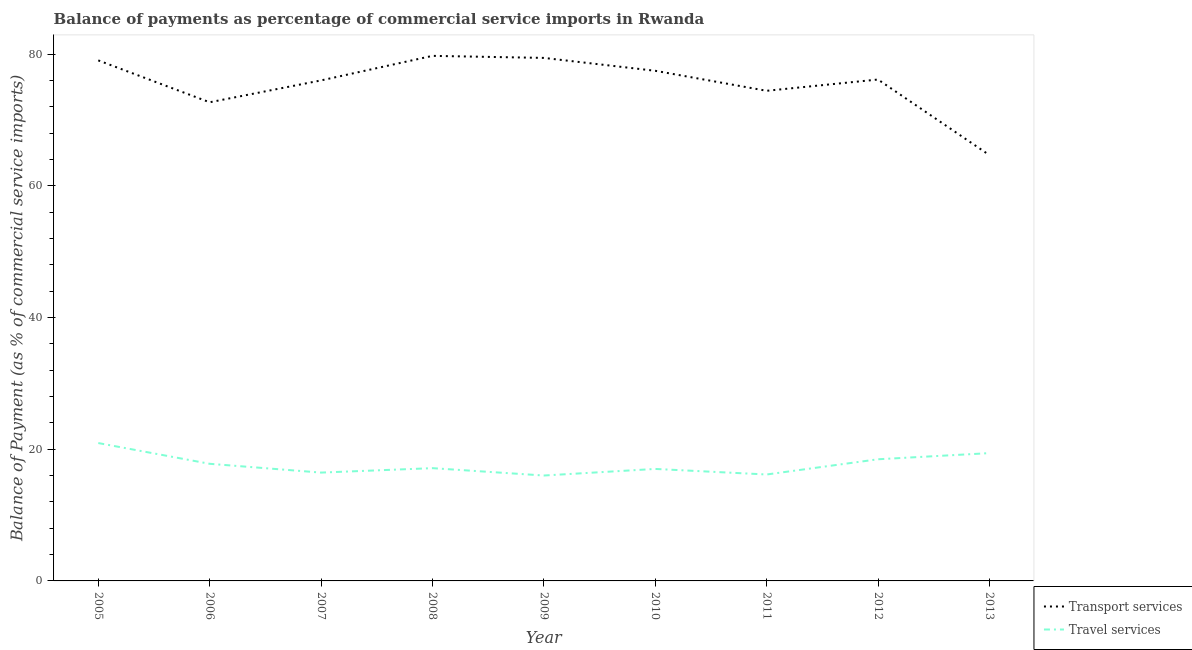How many different coloured lines are there?
Your answer should be compact. 2. What is the balance of payments of transport services in 2010?
Keep it short and to the point. 77.48. Across all years, what is the maximum balance of payments of travel services?
Provide a short and direct response. 20.94. Across all years, what is the minimum balance of payments of transport services?
Your answer should be very brief. 64.68. In which year was the balance of payments of travel services maximum?
Offer a very short reply. 2005. What is the total balance of payments of travel services in the graph?
Ensure brevity in your answer.  159.38. What is the difference between the balance of payments of transport services in 2007 and that in 2011?
Offer a very short reply. 1.58. What is the difference between the balance of payments of transport services in 2012 and the balance of payments of travel services in 2013?
Provide a short and direct response. 56.74. What is the average balance of payments of travel services per year?
Offer a very short reply. 17.71. In the year 2013, what is the difference between the balance of payments of transport services and balance of payments of travel services?
Keep it short and to the point. 45.26. What is the ratio of the balance of payments of travel services in 2009 to that in 2011?
Provide a short and direct response. 0.99. What is the difference between the highest and the second highest balance of payments of transport services?
Offer a very short reply. 0.31. What is the difference between the highest and the lowest balance of payments of travel services?
Offer a very short reply. 4.93. In how many years, is the balance of payments of transport services greater than the average balance of payments of transport services taken over all years?
Offer a very short reply. 6. Is the sum of the balance of payments of transport services in 2005 and 2012 greater than the maximum balance of payments of travel services across all years?
Offer a very short reply. Yes. Does the balance of payments of travel services monotonically increase over the years?
Ensure brevity in your answer.  No. Is the balance of payments of travel services strictly greater than the balance of payments of transport services over the years?
Provide a succinct answer. No. Is the balance of payments of transport services strictly less than the balance of payments of travel services over the years?
Give a very brief answer. No. How many years are there in the graph?
Your answer should be compact. 9. Are the values on the major ticks of Y-axis written in scientific E-notation?
Keep it short and to the point. No. Does the graph contain any zero values?
Give a very brief answer. No. Where does the legend appear in the graph?
Your answer should be very brief. Bottom right. How are the legend labels stacked?
Give a very brief answer. Vertical. What is the title of the graph?
Your answer should be compact. Balance of payments as percentage of commercial service imports in Rwanda. Does "Investments" appear as one of the legend labels in the graph?
Your answer should be compact. No. What is the label or title of the Y-axis?
Offer a very short reply. Balance of Payment (as % of commercial service imports). What is the Balance of Payment (as % of commercial service imports) in Transport services in 2005?
Provide a succinct answer. 79.06. What is the Balance of Payment (as % of commercial service imports) in Travel services in 2005?
Offer a terse response. 20.94. What is the Balance of Payment (as % of commercial service imports) in Transport services in 2006?
Offer a terse response. 72.7. What is the Balance of Payment (as % of commercial service imports) of Travel services in 2006?
Make the answer very short. 17.79. What is the Balance of Payment (as % of commercial service imports) of Transport services in 2007?
Keep it short and to the point. 76.02. What is the Balance of Payment (as % of commercial service imports) of Travel services in 2007?
Your answer should be compact. 16.45. What is the Balance of Payment (as % of commercial service imports) in Transport services in 2008?
Your response must be concise. 79.75. What is the Balance of Payment (as % of commercial service imports) in Travel services in 2008?
Ensure brevity in your answer.  17.13. What is the Balance of Payment (as % of commercial service imports) in Transport services in 2009?
Your answer should be compact. 79.44. What is the Balance of Payment (as % of commercial service imports) of Travel services in 2009?
Give a very brief answer. 16.01. What is the Balance of Payment (as % of commercial service imports) in Transport services in 2010?
Make the answer very short. 77.48. What is the Balance of Payment (as % of commercial service imports) in Travel services in 2010?
Keep it short and to the point. 17.01. What is the Balance of Payment (as % of commercial service imports) of Transport services in 2011?
Give a very brief answer. 74.44. What is the Balance of Payment (as % of commercial service imports) of Travel services in 2011?
Give a very brief answer. 16.16. What is the Balance of Payment (as % of commercial service imports) in Transport services in 2012?
Your response must be concise. 76.15. What is the Balance of Payment (as % of commercial service imports) in Travel services in 2012?
Your answer should be compact. 18.48. What is the Balance of Payment (as % of commercial service imports) in Transport services in 2013?
Keep it short and to the point. 64.68. What is the Balance of Payment (as % of commercial service imports) in Travel services in 2013?
Offer a terse response. 19.41. Across all years, what is the maximum Balance of Payment (as % of commercial service imports) of Transport services?
Your response must be concise. 79.75. Across all years, what is the maximum Balance of Payment (as % of commercial service imports) of Travel services?
Give a very brief answer. 20.94. Across all years, what is the minimum Balance of Payment (as % of commercial service imports) in Transport services?
Your response must be concise. 64.68. Across all years, what is the minimum Balance of Payment (as % of commercial service imports) of Travel services?
Offer a terse response. 16.01. What is the total Balance of Payment (as % of commercial service imports) in Transport services in the graph?
Give a very brief answer. 679.72. What is the total Balance of Payment (as % of commercial service imports) of Travel services in the graph?
Provide a short and direct response. 159.38. What is the difference between the Balance of Payment (as % of commercial service imports) in Transport services in 2005 and that in 2006?
Offer a very short reply. 6.36. What is the difference between the Balance of Payment (as % of commercial service imports) of Travel services in 2005 and that in 2006?
Offer a very short reply. 3.15. What is the difference between the Balance of Payment (as % of commercial service imports) in Transport services in 2005 and that in 2007?
Ensure brevity in your answer.  3.04. What is the difference between the Balance of Payment (as % of commercial service imports) of Travel services in 2005 and that in 2007?
Your answer should be compact. 4.49. What is the difference between the Balance of Payment (as % of commercial service imports) of Transport services in 2005 and that in 2008?
Offer a very short reply. -0.69. What is the difference between the Balance of Payment (as % of commercial service imports) in Travel services in 2005 and that in 2008?
Offer a terse response. 3.81. What is the difference between the Balance of Payment (as % of commercial service imports) in Transport services in 2005 and that in 2009?
Provide a short and direct response. -0.38. What is the difference between the Balance of Payment (as % of commercial service imports) of Travel services in 2005 and that in 2009?
Provide a short and direct response. 4.93. What is the difference between the Balance of Payment (as % of commercial service imports) in Transport services in 2005 and that in 2010?
Ensure brevity in your answer.  1.58. What is the difference between the Balance of Payment (as % of commercial service imports) in Travel services in 2005 and that in 2010?
Your response must be concise. 3.93. What is the difference between the Balance of Payment (as % of commercial service imports) of Transport services in 2005 and that in 2011?
Provide a short and direct response. 4.62. What is the difference between the Balance of Payment (as % of commercial service imports) of Travel services in 2005 and that in 2011?
Offer a terse response. 4.78. What is the difference between the Balance of Payment (as % of commercial service imports) in Transport services in 2005 and that in 2012?
Provide a succinct answer. 2.9. What is the difference between the Balance of Payment (as % of commercial service imports) in Travel services in 2005 and that in 2012?
Your response must be concise. 2.46. What is the difference between the Balance of Payment (as % of commercial service imports) in Transport services in 2005 and that in 2013?
Provide a succinct answer. 14.38. What is the difference between the Balance of Payment (as % of commercial service imports) of Travel services in 2005 and that in 2013?
Your answer should be compact. 1.53. What is the difference between the Balance of Payment (as % of commercial service imports) of Transport services in 2006 and that in 2007?
Ensure brevity in your answer.  -3.32. What is the difference between the Balance of Payment (as % of commercial service imports) in Travel services in 2006 and that in 2007?
Your answer should be compact. 1.34. What is the difference between the Balance of Payment (as % of commercial service imports) in Transport services in 2006 and that in 2008?
Your answer should be very brief. -7.05. What is the difference between the Balance of Payment (as % of commercial service imports) of Travel services in 2006 and that in 2008?
Provide a succinct answer. 0.66. What is the difference between the Balance of Payment (as % of commercial service imports) in Transport services in 2006 and that in 2009?
Offer a very short reply. -6.74. What is the difference between the Balance of Payment (as % of commercial service imports) in Travel services in 2006 and that in 2009?
Offer a terse response. 1.78. What is the difference between the Balance of Payment (as % of commercial service imports) of Transport services in 2006 and that in 2010?
Provide a short and direct response. -4.78. What is the difference between the Balance of Payment (as % of commercial service imports) in Travel services in 2006 and that in 2010?
Offer a terse response. 0.78. What is the difference between the Balance of Payment (as % of commercial service imports) in Transport services in 2006 and that in 2011?
Your answer should be very brief. -1.74. What is the difference between the Balance of Payment (as % of commercial service imports) of Travel services in 2006 and that in 2011?
Offer a very short reply. 1.62. What is the difference between the Balance of Payment (as % of commercial service imports) in Transport services in 2006 and that in 2012?
Ensure brevity in your answer.  -3.46. What is the difference between the Balance of Payment (as % of commercial service imports) in Travel services in 2006 and that in 2012?
Provide a succinct answer. -0.69. What is the difference between the Balance of Payment (as % of commercial service imports) of Transport services in 2006 and that in 2013?
Provide a succinct answer. 8.02. What is the difference between the Balance of Payment (as % of commercial service imports) of Travel services in 2006 and that in 2013?
Provide a short and direct response. -1.62. What is the difference between the Balance of Payment (as % of commercial service imports) of Transport services in 2007 and that in 2008?
Your response must be concise. -3.73. What is the difference between the Balance of Payment (as % of commercial service imports) of Travel services in 2007 and that in 2008?
Give a very brief answer. -0.67. What is the difference between the Balance of Payment (as % of commercial service imports) in Transport services in 2007 and that in 2009?
Offer a very short reply. -3.42. What is the difference between the Balance of Payment (as % of commercial service imports) of Travel services in 2007 and that in 2009?
Offer a very short reply. 0.45. What is the difference between the Balance of Payment (as % of commercial service imports) in Transport services in 2007 and that in 2010?
Your answer should be compact. -1.46. What is the difference between the Balance of Payment (as % of commercial service imports) of Travel services in 2007 and that in 2010?
Keep it short and to the point. -0.56. What is the difference between the Balance of Payment (as % of commercial service imports) of Transport services in 2007 and that in 2011?
Your answer should be very brief. 1.58. What is the difference between the Balance of Payment (as % of commercial service imports) of Travel services in 2007 and that in 2011?
Offer a terse response. 0.29. What is the difference between the Balance of Payment (as % of commercial service imports) of Transport services in 2007 and that in 2012?
Ensure brevity in your answer.  -0.14. What is the difference between the Balance of Payment (as % of commercial service imports) in Travel services in 2007 and that in 2012?
Provide a succinct answer. -2.02. What is the difference between the Balance of Payment (as % of commercial service imports) in Transport services in 2007 and that in 2013?
Your response must be concise. 11.34. What is the difference between the Balance of Payment (as % of commercial service imports) of Travel services in 2007 and that in 2013?
Your response must be concise. -2.96. What is the difference between the Balance of Payment (as % of commercial service imports) in Transport services in 2008 and that in 2009?
Make the answer very short. 0.31. What is the difference between the Balance of Payment (as % of commercial service imports) of Travel services in 2008 and that in 2009?
Offer a very short reply. 1.12. What is the difference between the Balance of Payment (as % of commercial service imports) in Transport services in 2008 and that in 2010?
Keep it short and to the point. 2.27. What is the difference between the Balance of Payment (as % of commercial service imports) in Travel services in 2008 and that in 2010?
Your answer should be compact. 0.12. What is the difference between the Balance of Payment (as % of commercial service imports) of Transport services in 2008 and that in 2011?
Offer a terse response. 5.31. What is the difference between the Balance of Payment (as % of commercial service imports) of Travel services in 2008 and that in 2011?
Ensure brevity in your answer.  0.96. What is the difference between the Balance of Payment (as % of commercial service imports) of Transport services in 2008 and that in 2012?
Offer a very short reply. 3.59. What is the difference between the Balance of Payment (as % of commercial service imports) in Travel services in 2008 and that in 2012?
Ensure brevity in your answer.  -1.35. What is the difference between the Balance of Payment (as % of commercial service imports) of Transport services in 2008 and that in 2013?
Offer a very short reply. 15.07. What is the difference between the Balance of Payment (as % of commercial service imports) in Travel services in 2008 and that in 2013?
Offer a very short reply. -2.28. What is the difference between the Balance of Payment (as % of commercial service imports) in Transport services in 2009 and that in 2010?
Ensure brevity in your answer.  1.96. What is the difference between the Balance of Payment (as % of commercial service imports) in Travel services in 2009 and that in 2010?
Your response must be concise. -1. What is the difference between the Balance of Payment (as % of commercial service imports) of Transport services in 2009 and that in 2011?
Your answer should be compact. 4.99. What is the difference between the Balance of Payment (as % of commercial service imports) of Travel services in 2009 and that in 2011?
Offer a very short reply. -0.16. What is the difference between the Balance of Payment (as % of commercial service imports) in Transport services in 2009 and that in 2012?
Give a very brief answer. 3.28. What is the difference between the Balance of Payment (as % of commercial service imports) of Travel services in 2009 and that in 2012?
Keep it short and to the point. -2.47. What is the difference between the Balance of Payment (as % of commercial service imports) in Transport services in 2009 and that in 2013?
Provide a succinct answer. 14.76. What is the difference between the Balance of Payment (as % of commercial service imports) in Travel services in 2009 and that in 2013?
Give a very brief answer. -3.4. What is the difference between the Balance of Payment (as % of commercial service imports) of Transport services in 2010 and that in 2011?
Your answer should be compact. 3.04. What is the difference between the Balance of Payment (as % of commercial service imports) of Travel services in 2010 and that in 2011?
Make the answer very short. 0.84. What is the difference between the Balance of Payment (as % of commercial service imports) of Transport services in 2010 and that in 2012?
Offer a terse response. 1.33. What is the difference between the Balance of Payment (as % of commercial service imports) of Travel services in 2010 and that in 2012?
Provide a succinct answer. -1.47. What is the difference between the Balance of Payment (as % of commercial service imports) in Transport services in 2010 and that in 2013?
Provide a short and direct response. 12.81. What is the difference between the Balance of Payment (as % of commercial service imports) of Travel services in 2010 and that in 2013?
Keep it short and to the point. -2.4. What is the difference between the Balance of Payment (as % of commercial service imports) in Transport services in 2011 and that in 2012?
Ensure brevity in your answer.  -1.71. What is the difference between the Balance of Payment (as % of commercial service imports) of Travel services in 2011 and that in 2012?
Offer a terse response. -2.31. What is the difference between the Balance of Payment (as % of commercial service imports) of Transport services in 2011 and that in 2013?
Ensure brevity in your answer.  9.77. What is the difference between the Balance of Payment (as % of commercial service imports) in Travel services in 2011 and that in 2013?
Your answer should be very brief. -3.25. What is the difference between the Balance of Payment (as % of commercial service imports) of Transport services in 2012 and that in 2013?
Provide a short and direct response. 11.48. What is the difference between the Balance of Payment (as % of commercial service imports) of Travel services in 2012 and that in 2013?
Offer a terse response. -0.93. What is the difference between the Balance of Payment (as % of commercial service imports) of Transport services in 2005 and the Balance of Payment (as % of commercial service imports) of Travel services in 2006?
Your answer should be compact. 61.27. What is the difference between the Balance of Payment (as % of commercial service imports) of Transport services in 2005 and the Balance of Payment (as % of commercial service imports) of Travel services in 2007?
Provide a succinct answer. 62.61. What is the difference between the Balance of Payment (as % of commercial service imports) of Transport services in 2005 and the Balance of Payment (as % of commercial service imports) of Travel services in 2008?
Provide a succinct answer. 61.93. What is the difference between the Balance of Payment (as % of commercial service imports) in Transport services in 2005 and the Balance of Payment (as % of commercial service imports) in Travel services in 2009?
Offer a terse response. 63.05. What is the difference between the Balance of Payment (as % of commercial service imports) of Transport services in 2005 and the Balance of Payment (as % of commercial service imports) of Travel services in 2010?
Your answer should be compact. 62.05. What is the difference between the Balance of Payment (as % of commercial service imports) in Transport services in 2005 and the Balance of Payment (as % of commercial service imports) in Travel services in 2011?
Give a very brief answer. 62.9. What is the difference between the Balance of Payment (as % of commercial service imports) of Transport services in 2005 and the Balance of Payment (as % of commercial service imports) of Travel services in 2012?
Your answer should be compact. 60.58. What is the difference between the Balance of Payment (as % of commercial service imports) in Transport services in 2005 and the Balance of Payment (as % of commercial service imports) in Travel services in 2013?
Keep it short and to the point. 59.65. What is the difference between the Balance of Payment (as % of commercial service imports) in Transport services in 2006 and the Balance of Payment (as % of commercial service imports) in Travel services in 2007?
Make the answer very short. 56.24. What is the difference between the Balance of Payment (as % of commercial service imports) in Transport services in 2006 and the Balance of Payment (as % of commercial service imports) in Travel services in 2008?
Your answer should be compact. 55.57. What is the difference between the Balance of Payment (as % of commercial service imports) in Transport services in 2006 and the Balance of Payment (as % of commercial service imports) in Travel services in 2009?
Make the answer very short. 56.69. What is the difference between the Balance of Payment (as % of commercial service imports) of Transport services in 2006 and the Balance of Payment (as % of commercial service imports) of Travel services in 2010?
Make the answer very short. 55.69. What is the difference between the Balance of Payment (as % of commercial service imports) in Transport services in 2006 and the Balance of Payment (as % of commercial service imports) in Travel services in 2011?
Provide a short and direct response. 56.53. What is the difference between the Balance of Payment (as % of commercial service imports) in Transport services in 2006 and the Balance of Payment (as % of commercial service imports) in Travel services in 2012?
Provide a succinct answer. 54.22. What is the difference between the Balance of Payment (as % of commercial service imports) in Transport services in 2006 and the Balance of Payment (as % of commercial service imports) in Travel services in 2013?
Your answer should be compact. 53.29. What is the difference between the Balance of Payment (as % of commercial service imports) in Transport services in 2007 and the Balance of Payment (as % of commercial service imports) in Travel services in 2008?
Your answer should be very brief. 58.89. What is the difference between the Balance of Payment (as % of commercial service imports) of Transport services in 2007 and the Balance of Payment (as % of commercial service imports) of Travel services in 2009?
Give a very brief answer. 60.01. What is the difference between the Balance of Payment (as % of commercial service imports) in Transport services in 2007 and the Balance of Payment (as % of commercial service imports) in Travel services in 2010?
Provide a short and direct response. 59.01. What is the difference between the Balance of Payment (as % of commercial service imports) in Transport services in 2007 and the Balance of Payment (as % of commercial service imports) in Travel services in 2011?
Ensure brevity in your answer.  59.86. What is the difference between the Balance of Payment (as % of commercial service imports) in Transport services in 2007 and the Balance of Payment (as % of commercial service imports) in Travel services in 2012?
Provide a succinct answer. 57.54. What is the difference between the Balance of Payment (as % of commercial service imports) of Transport services in 2007 and the Balance of Payment (as % of commercial service imports) of Travel services in 2013?
Give a very brief answer. 56.61. What is the difference between the Balance of Payment (as % of commercial service imports) in Transport services in 2008 and the Balance of Payment (as % of commercial service imports) in Travel services in 2009?
Offer a terse response. 63.74. What is the difference between the Balance of Payment (as % of commercial service imports) in Transport services in 2008 and the Balance of Payment (as % of commercial service imports) in Travel services in 2010?
Offer a very short reply. 62.74. What is the difference between the Balance of Payment (as % of commercial service imports) in Transport services in 2008 and the Balance of Payment (as % of commercial service imports) in Travel services in 2011?
Your answer should be very brief. 63.58. What is the difference between the Balance of Payment (as % of commercial service imports) in Transport services in 2008 and the Balance of Payment (as % of commercial service imports) in Travel services in 2012?
Your answer should be very brief. 61.27. What is the difference between the Balance of Payment (as % of commercial service imports) in Transport services in 2008 and the Balance of Payment (as % of commercial service imports) in Travel services in 2013?
Provide a short and direct response. 60.34. What is the difference between the Balance of Payment (as % of commercial service imports) of Transport services in 2009 and the Balance of Payment (as % of commercial service imports) of Travel services in 2010?
Provide a short and direct response. 62.43. What is the difference between the Balance of Payment (as % of commercial service imports) of Transport services in 2009 and the Balance of Payment (as % of commercial service imports) of Travel services in 2011?
Ensure brevity in your answer.  63.27. What is the difference between the Balance of Payment (as % of commercial service imports) of Transport services in 2009 and the Balance of Payment (as % of commercial service imports) of Travel services in 2012?
Make the answer very short. 60.96. What is the difference between the Balance of Payment (as % of commercial service imports) of Transport services in 2009 and the Balance of Payment (as % of commercial service imports) of Travel services in 2013?
Give a very brief answer. 60.03. What is the difference between the Balance of Payment (as % of commercial service imports) in Transport services in 2010 and the Balance of Payment (as % of commercial service imports) in Travel services in 2011?
Ensure brevity in your answer.  61.32. What is the difference between the Balance of Payment (as % of commercial service imports) in Transport services in 2010 and the Balance of Payment (as % of commercial service imports) in Travel services in 2012?
Offer a terse response. 59. What is the difference between the Balance of Payment (as % of commercial service imports) of Transport services in 2010 and the Balance of Payment (as % of commercial service imports) of Travel services in 2013?
Ensure brevity in your answer.  58.07. What is the difference between the Balance of Payment (as % of commercial service imports) of Transport services in 2011 and the Balance of Payment (as % of commercial service imports) of Travel services in 2012?
Keep it short and to the point. 55.97. What is the difference between the Balance of Payment (as % of commercial service imports) of Transport services in 2011 and the Balance of Payment (as % of commercial service imports) of Travel services in 2013?
Your response must be concise. 55.03. What is the difference between the Balance of Payment (as % of commercial service imports) in Transport services in 2012 and the Balance of Payment (as % of commercial service imports) in Travel services in 2013?
Make the answer very short. 56.74. What is the average Balance of Payment (as % of commercial service imports) of Transport services per year?
Give a very brief answer. 75.52. What is the average Balance of Payment (as % of commercial service imports) of Travel services per year?
Ensure brevity in your answer.  17.71. In the year 2005, what is the difference between the Balance of Payment (as % of commercial service imports) of Transport services and Balance of Payment (as % of commercial service imports) of Travel services?
Your answer should be very brief. 58.12. In the year 2006, what is the difference between the Balance of Payment (as % of commercial service imports) in Transport services and Balance of Payment (as % of commercial service imports) in Travel services?
Offer a very short reply. 54.91. In the year 2007, what is the difference between the Balance of Payment (as % of commercial service imports) of Transport services and Balance of Payment (as % of commercial service imports) of Travel services?
Your answer should be compact. 59.57. In the year 2008, what is the difference between the Balance of Payment (as % of commercial service imports) in Transport services and Balance of Payment (as % of commercial service imports) in Travel services?
Your answer should be very brief. 62.62. In the year 2009, what is the difference between the Balance of Payment (as % of commercial service imports) in Transport services and Balance of Payment (as % of commercial service imports) in Travel services?
Offer a terse response. 63.43. In the year 2010, what is the difference between the Balance of Payment (as % of commercial service imports) in Transport services and Balance of Payment (as % of commercial service imports) in Travel services?
Your response must be concise. 60.47. In the year 2011, what is the difference between the Balance of Payment (as % of commercial service imports) of Transport services and Balance of Payment (as % of commercial service imports) of Travel services?
Your answer should be very brief. 58.28. In the year 2012, what is the difference between the Balance of Payment (as % of commercial service imports) in Transport services and Balance of Payment (as % of commercial service imports) in Travel services?
Offer a very short reply. 57.68. In the year 2013, what is the difference between the Balance of Payment (as % of commercial service imports) in Transport services and Balance of Payment (as % of commercial service imports) in Travel services?
Your answer should be very brief. 45.26. What is the ratio of the Balance of Payment (as % of commercial service imports) in Transport services in 2005 to that in 2006?
Ensure brevity in your answer.  1.09. What is the ratio of the Balance of Payment (as % of commercial service imports) of Travel services in 2005 to that in 2006?
Give a very brief answer. 1.18. What is the ratio of the Balance of Payment (as % of commercial service imports) in Transport services in 2005 to that in 2007?
Provide a succinct answer. 1.04. What is the ratio of the Balance of Payment (as % of commercial service imports) in Travel services in 2005 to that in 2007?
Your answer should be very brief. 1.27. What is the ratio of the Balance of Payment (as % of commercial service imports) of Travel services in 2005 to that in 2008?
Offer a terse response. 1.22. What is the ratio of the Balance of Payment (as % of commercial service imports) in Transport services in 2005 to that in 2009?
Your answer should be compact. 1. What is the ratio of the Balance of Payment (as % of commercial service imports) in Travel services in 2005 to that in 2009?
Give a very brief answer. 1.31. What is the ratio of the Balance of Payment (as % of commercial service imports) of Transport services in 2005 to that in 2010?
Provide a succinct answer. 1.02. What is the ratio of the Balance of Payment (as % of commercial service imports) in Travel services in 2005 to that in 2010?
Your answer should be compact. 1.23. What is the ratio of the Balance of Payment (as % of commercial service imports) of Transport services in 2005 to that in 2011?
Make the answer very short. 1.06. What is the ratio of the Balance of Payment (as % of commercial service imports) in Travel services in 2005 to that in 2011?
Your response must be concise. 1.3. What is the ratio of the Balance of Payment (as % of commercial service imports) in Transport services in 2005 to that in 2012?
Your answer should be compact. 1.04. What is the ratio of the Balance of Payment (as % of commercial service imports) of Travel services in 2005 to that in 2012?
Provide a succinct answer. 1.13. What is the ratio of the Balance of Payment (as % of commercial service imports) in Transport services in 2005 to that in 2013?
Make the answer very short. 1.22. What is the ratio of the Balance of Payment (as % of commercial service imports) of Travel services in 2005 to that in 2013?
Your answer should be very brief. 1.08. What is the ratio of the Balance of Payment (as % of commercial service imports) of Transport services in 2006 to that in 2007?
Provide a short and direct response. 0.96. What is the ratio of the Balance of Payment (as % of commercial service imports) in Travel services in 2006 to that in 2007?
Offer a very short reply. 1.08. What is the ratio of the Balance of Payment (as % of commercial service imports) of Transport services in 2006 to that in 2008?
Provide a succinct answer. 0.91. What is the ratio of the Balance of Payment (as % of commercial service imports) in Travel services in 2006 to that in 2008?
Keep it short and to the point. 1.04. What is the ratio of the Balance of Payment (as % of commercial service imports) of Transport services in 2006 to that in 2009?
Offer a terse response. 0.92. What is the ratio of the Balance of Payment (as % of commercial service imports) of Travel services in 2006 to that in 2009?
Make the answer very short. 1.11. What is the ratio of the Balance of Payment (as % of commercial service imports) in Transport services in 2006 to that in 2010?
Give a very brief answer. 0.94. What is the ratio of the Balance of Payment (as % of commercial service imports) in Travel services in 2006 to that in 2010?
Offer a terse response. 1.05. What is the ratio of the Balance of Payment (as % of commercial service imports) of Transport services in 2006 to that in 2011?
Your answer should be compact. 0.98. What is the ratio of the Balance of Payment (as % of commercial service imports) in Travel services in 2006 to that in 2011?
Provide a succinct answer. 1.1. What is the ratio of the Balance of Payment (as % of commercial service imports) in Transport services in 2006 to that in 2012?
Your answer should be very brief. 0.95. What is the ratio of the Balance of Payment (as % of commercial service imports) in Travel services in 2006 to that in 2012?
Ensure brevity in your answer.  0.96. What is the ratio of the Balance of Payment (as % of commercial service imports) in Transport services in 2006 to that in 2013?
Provide a short and direct response. 1.12. What is the ratio of the Balance of Payment (as % of commercial service imports) of Travel services in 2006 to that in 2013?
Offer a very short reply. 0.92. What is the ratio of the Balance of Payment (as % of commercial service imports) in Transport services in 2007 to that in 2008?
Make the answer very short. 0.95. What is the ratio of the Balance of Payment (as % of commercial service imports) of Travel services in 2007 to that in 2008?
Provide a short and direct response. 0.96. What is the ratio of the Balance of Payment (as % of commercial service imports) in Travel services in 2007 to that in 2009?
Offer a terse response. 1.03. What is the ratio of the Balance of Payment (as % of commercial service imports) in Transport services in 2007 to that in 2010?
Keep it short and to the point. 0.98. What is the ratio of the Balance of Payment (as % of commercial service imports) in Travel services in 2007 to that in 2010?
Offer a very short reply. 0.97. What is the ratio of the Balance of Payment (as % of commercial service imports) in Transport services in 2007 to that in 2011?
Provide a short and direct response. 1.02. What is the ratio of the Balance of Payment (as % of commercial service imports) of Travel services in 2007 to that in 2011?
Ensure brevity in your answer.  1.02. What is the ratio of the Balance of Payment (as % of commercial service imports) of Travel services in 2007 to that in 2012?
Provide a succinct answer. 0.89. What is the ratio of the Balance of Payment (as % of commercial service imports) of Transport services in 2007 to that in 2013?
Your response must be concise. 1.18. What is the ratio of the Balance of Payment (as % of commercial service imports) in Travel services in 2007 to that in 2013?
Make the answer very short. 0.85. What is the ratio of the Balance of Payment (as % of commercial service imports) of Travel services in 2008 to that in 2009?
Keep it short and to the point. 1.07. What is the ratio of the Balance of Payment (as % of commercial service imports) in Transport services in 2008 to that in 2010?
Provide a short and direct response. 1.03. What is the ratio of the Balance of Payment (as % of commercial service imports) in Transport services in 2008 to that in 2011?
Give a very brief answer. 1.07. What is the ratio of the Balance of Payment (as % of commercial service imports) in Travel services in 2008 to that in 2011?
Your answer should be compact. 1.06. What is the ratio of the Balance of Payment (as % of commercial service imports) in Transport services in 2008 to that in 2012?
Make the answer very short. 1.05. What is the ratio of the Balance of Payment (as % of commercial service imports) of Travel services in 2008 to that in 2012?
Offer a very short reply. 0.93. What is the ratio of the Balance of Payment (as % of commercial service imports) of Transport services in 2008 to that in 2013?
Make the answer very short. 1.23. What is the ratio of the Balance of Payment (as % of commercial service imports) of Travel services in 2008 to that in 2013?
Ensure brevity in your answer.  0.88. What is the ratio of the Balance of Payment (as % of commercial service imports) in Transport services in 2009 to that in 2010?
Provide a short and direct response. 1.03. What is the ratio of the Balance of Payment (as % of commercial service imports) in Travel services in 2009 to that in 2010?
Give a very brief answer. 0.94. What is the ratio of the Balance of Payment (as % of commercial service imports) of Transport services in 2009 to that in 2011?
Your answer should be very brief. 1.07. What is the ratio of the Balance of Payment (as % of commercial service imports) of Transport services in 2009 to that in 2012?
Your response must be concise. 1.04. What is the ratio of the Balance of Payment (as % of commercial service imports) of Travel services in 2009 to that in 2012?
Make the answer very short. 0.87. What is the ratio of the Balance of Payment (as % of commercial service imports) of Transport services in 2009 to that in 2013?
Make the answer very short. 1.23. What is the ratio of the Balance of Payment (as % of commercial service imports) in Travel services in 2009 to that in 2013?
Keep it short and to the point. 0.82. What is the ratio of the Balance of Payment (as % of commercial service imports) of Transport services in 2010 to that in 2011?
Give a very brief answer. 1.04. What is the ratio of the Balance of Payment (as % of commercial service imports) of Travel services in 2010 to that in 2011?
Provide a short and direct response. 1.05. What is the ratio of the Balance of Payment (as % of commercial service imports) in Transport services in 2010 to that in 2012?
Provide a short and direct response. 1.02. What is the ratio of the Balance of Payment (as % of commercial service imports) in Travel services in 2010 to that in 2012?
Ensure brevity in your answer.  0.92. What is the ratio of the Balance of Payment (as % of commercial service imports) of Transport services in 2010 to that in 2013?
Offer a terse response. 1.2. What is the ratio of the Balance of Payment (as % of commercial service imports) of Travel services in 2010 to that in 2013?
Provide a succinct answer. 0.88. What is the ratio of the Balance of Payment (as % of commercial service imports) of Transport services in 2011 to that in 2012?
Your answer should be very brief. 0.98. What is the ratio of the Balance of Payment (as % of commercial service imports) of Travel services in 2011 to that in 2012?
Ensure brevity in your answer.  0.87. What is the ratio of the Balance of Payment (as % of commercial service imports) in Transport services in 2011 to that in 2013?
Your answer should be very brief. 1.15. What is the ratio of the Balance of Payment (as % of commercial service imports) in Travel services in 2011 to that in 2013?
Your answer should be very brief. 0.83. What is the ratio of the Balance of Payment (as % of commercial service imports) of Transport services in 2012 to that in 2013?
Provide a short and direct response. 1.18. What is the ratio of the Balance of Payment (as % of commercial service imports) in Travel services in 2012 to that in 2013?
Provide a short and direct response. 0.95. What is the difference between the highest and the second highest Balance of Payment (as % of commercial service imports) of Transport services?
Your response must be concise. 0.31. What is the difference between the highest and the second highest Balance of Payment (as % of commercial service imports) in Travel services?
Keep it short and to the point. 1.53. What is the difference between the highest and the lowest Balance of Payment (as % of commercial service imports) in Transport services?
Provide a short and direct response. 15.07. What is the difference between the highest and the lowest Balance of Payment (as % of commercial service imports) in Travel services?
Provide a succinct answer. 4.93. 